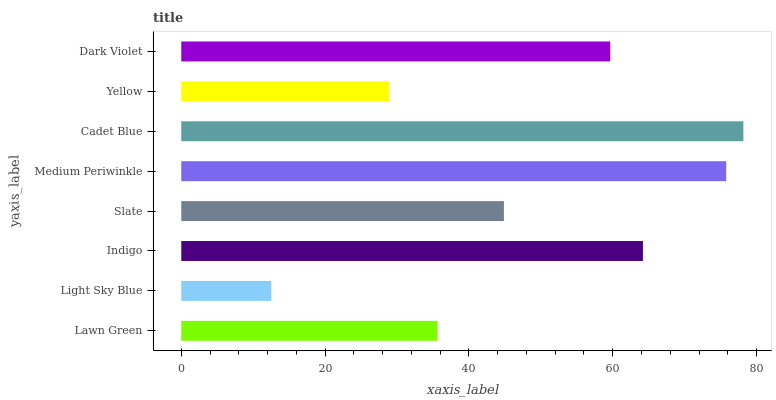Is Light Sky Blue the minimum?
Answer yes or no. Yes. Is Cadet Blue the maximum?
Answer yes or no. Yes. Is Indigo the minimum?
Answer yes or no. No. Is Indigo the maximum?
Answer yes or no. No. Is Indigo greater than Light Sky Blue?
Answer yes or no. Yes. Is Light Sky Blue less than Indigo?
Answer yes or no. Yes. Is Light Sky Blue greater than Indigo?
Answer yes or no. No. Is Indigo less than Light Sky Blue?
Answer yes or no. No. Is Dark Violet the high median?
Answer yes or no. Yes. Is Slate the low median?
Answer yes or no. Yes. Is Medium Periwinkle the high median?
Answer yes or no. No. Is Yellow the low median?
Answer yes or no. No. 